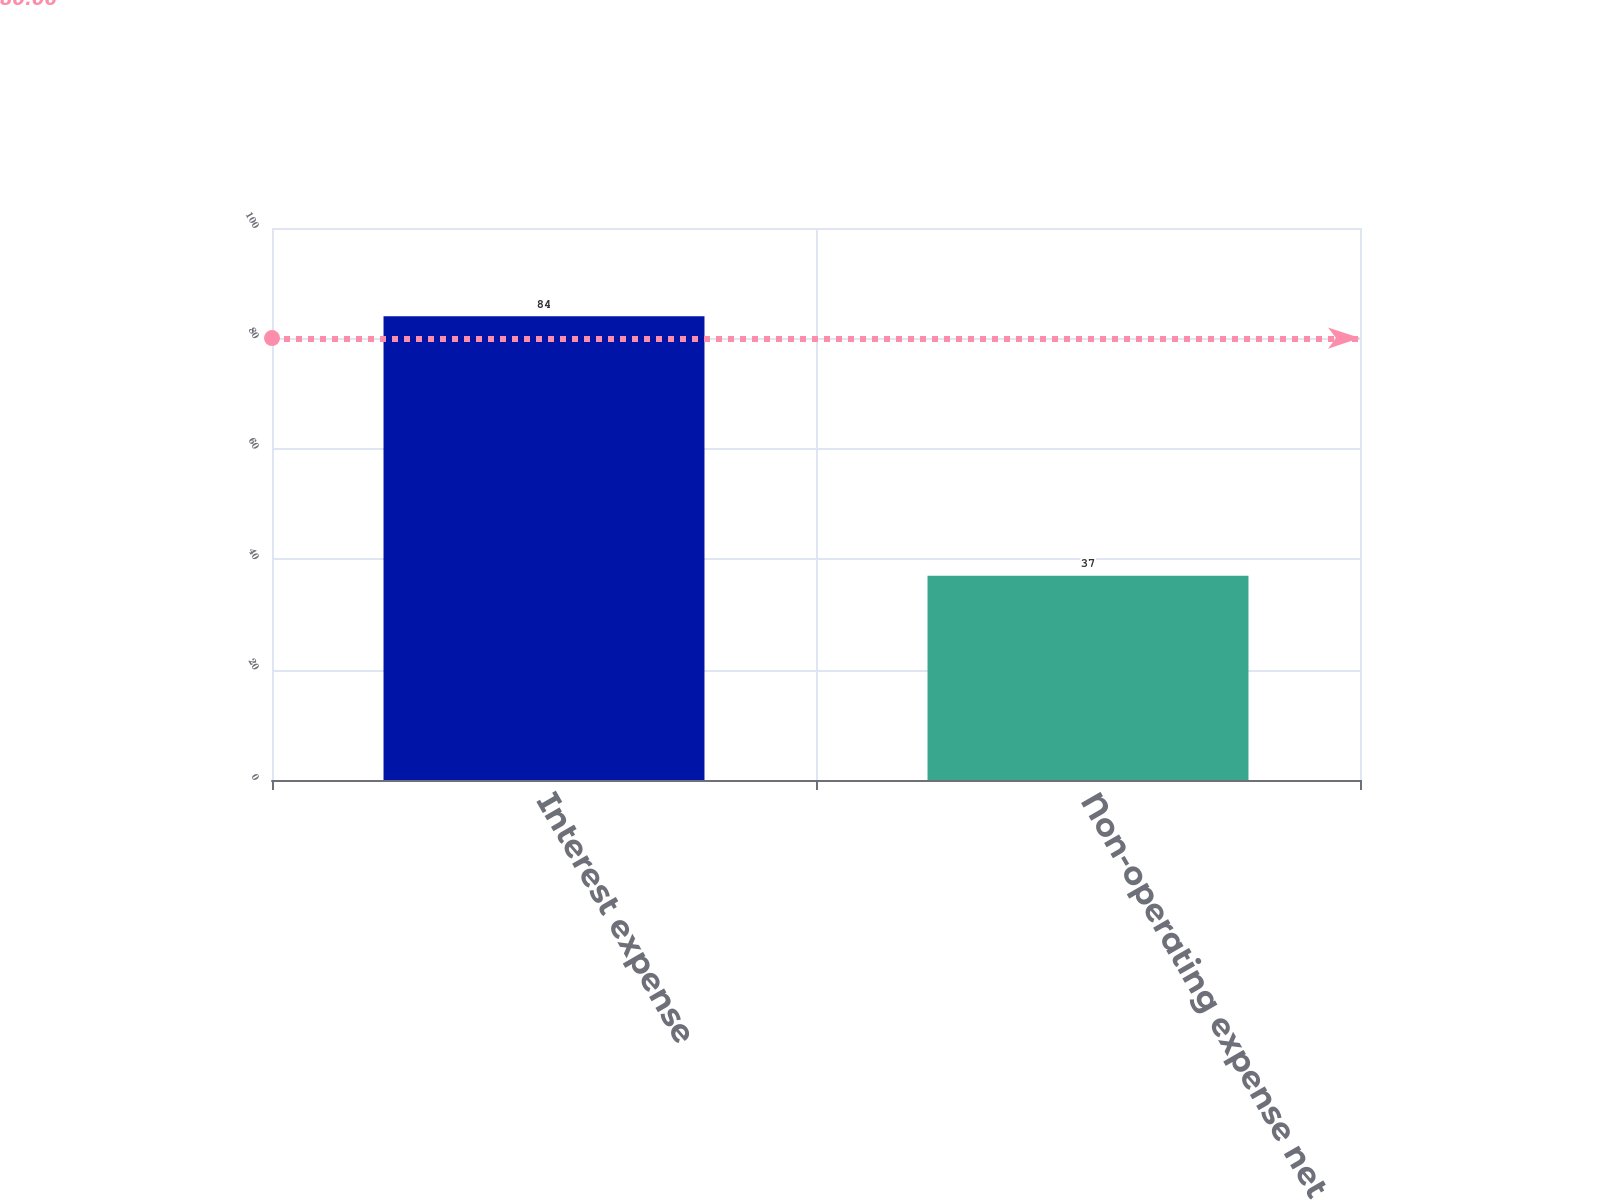Convert chart to OTSL. <chart><loc_0><loc_0><loc_500><loc_500><bar_chart><fcel>Interest expense<fcel>Non-operating expense net<nl><fcel>84<fcel>37<nl></chart> 